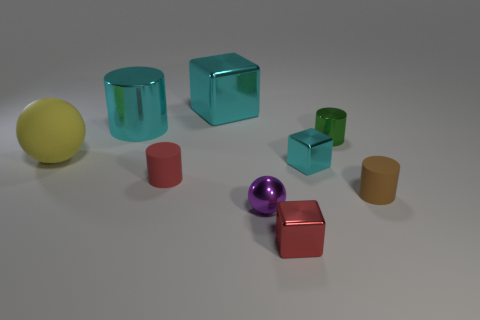Add 1 yellow rubber objects. How many objects exist? 10 Subtract all cylinders. How many objects are left? 5 Subtract 0 blue cylinders. How many objects are left? 9 Subtract all small red rubber spheres. Subtract all large cyan cylinders. How many objects are left? 8 Add 7 cyan metal blocks. How many cyan metal blocks are left? 9 Add 7 big cyan blocks. How many big cyan blocks exist? 8 